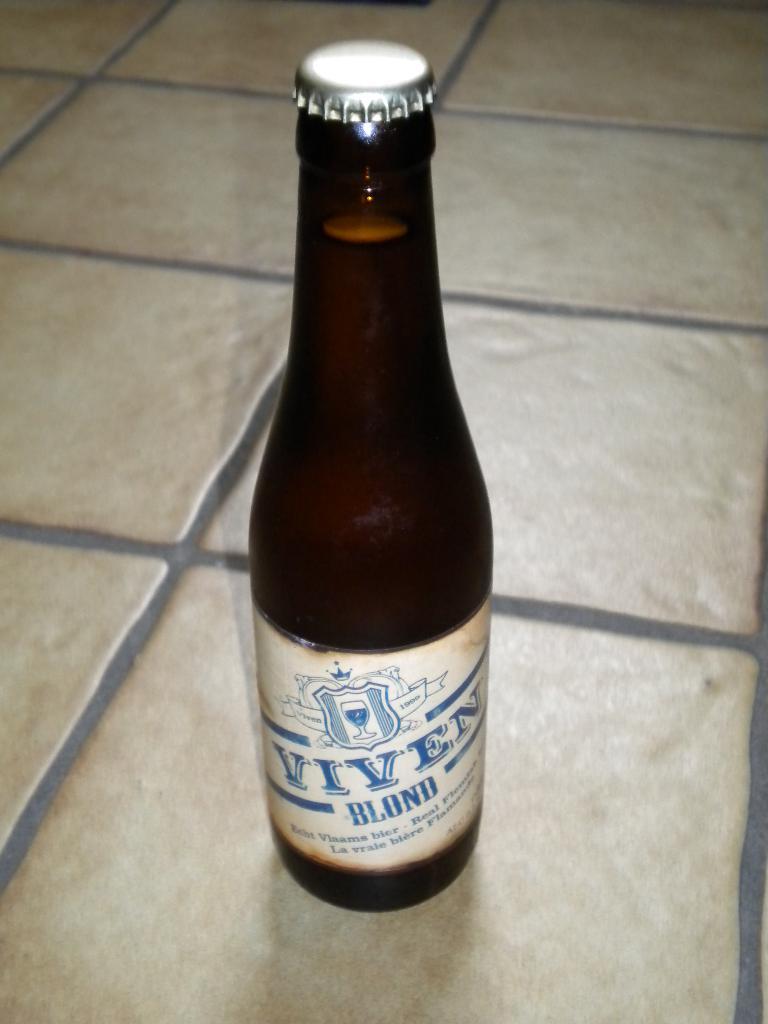What kind of wine is this?
Make the answer very short. Viven blond. What brand of beer?
Ensure brevity in your answer.  Viven. 